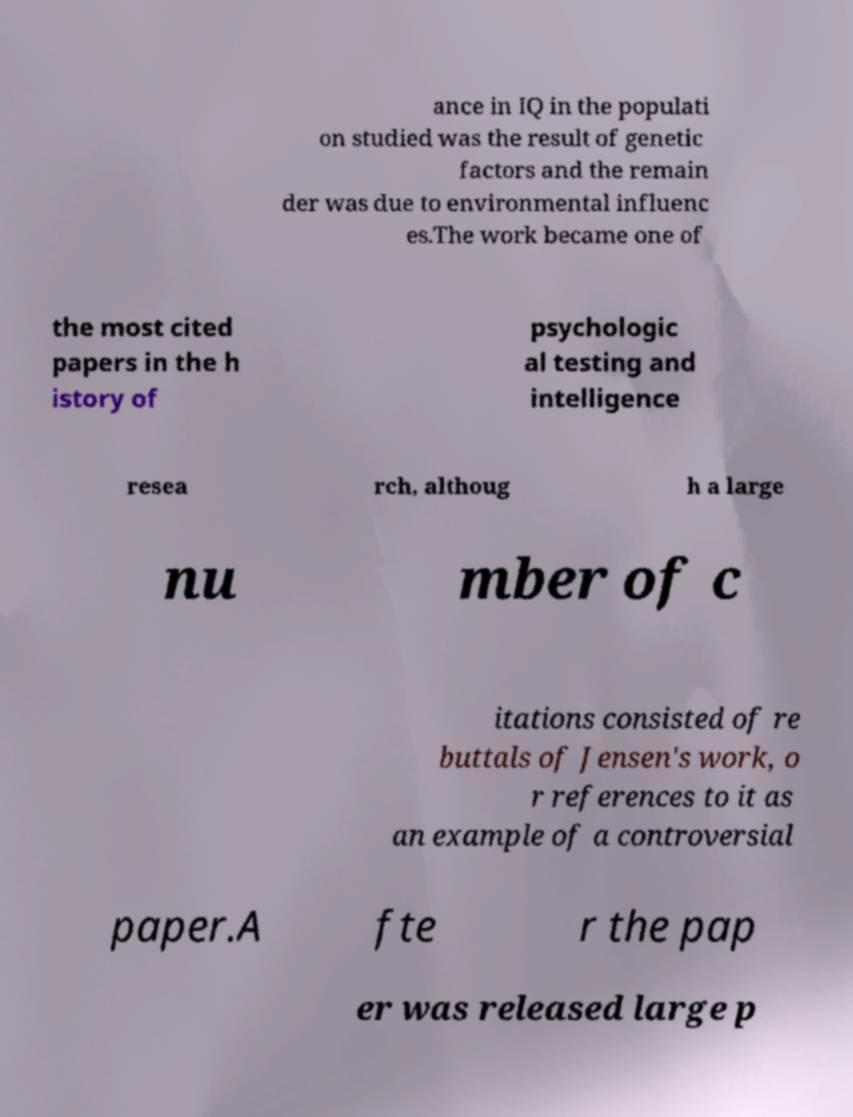What messages or text are displayed in this image? I need them in a readable, typed format. ance in IQ in the populati on studied was the result of genetic factors and the remain der was due to environmental influenc es.The work became one of the most cited papers in the h istory of psychologic al testing and intelligence resea rch, althoug h a large nu mber of c itations consisted of re buttals of Jensen's work, o r references to it as an example of a controversial paper.A fte r the pap er was released large p 